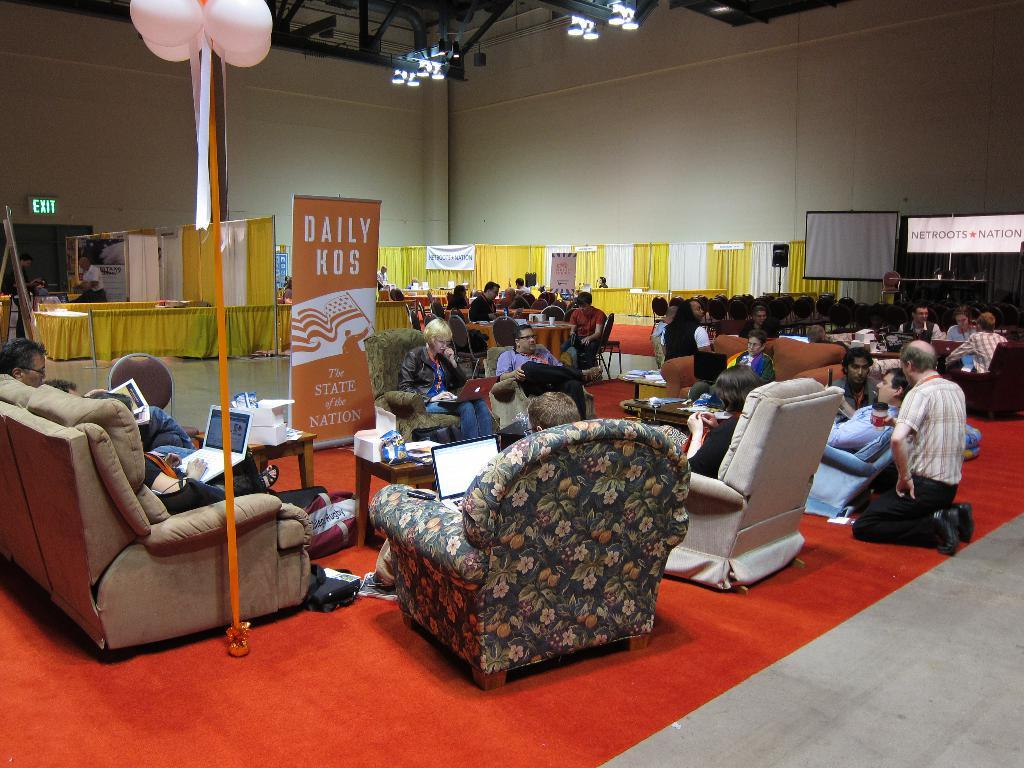What are the people in the image doing? The people in the image are sitting in sofas in a hall. What can be seen in the background of the image? In the background, there are stalls, a screen, a banner, balloons on a pole, and lights. Can you describe the seating arrangement in the hall? The people are sitting in sofas in the hall. What might be happening at the stalls in the background? The stalls in the background could be selling items or providing services, but this cannot be determined from the image alone. How does the person in the image use a whip to control the edge of the sofa? There is no person using a whip to control the edge of the sofa in the image. 